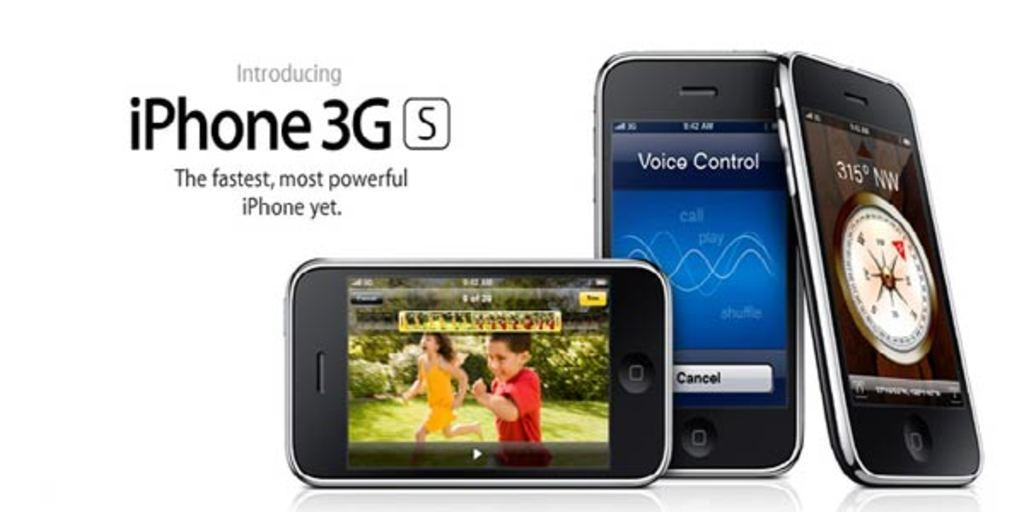<image>
Share a concise interpretation of the image provided. An ad for iPhone 3GS says it's the fastest and most powerful iPhone yet. 